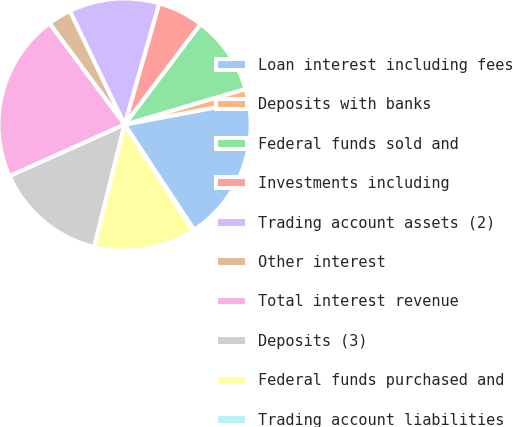Convert chart. <chart><loc_0><loc_0><loc_500><loc_500><pie_chart><fcel>Loan interest including fees<fcel>Deposits with banks<fcel>Federal funds sold and<fcel>Investments including<fcel>Trading account assets (2)<fcel>Other interest<fcel>Total interest revenue<fcel>Deposits (3)<fcel>Federal funds purchased and<fcel>Trading account liabilities<nl><fcel>18.69%<fcel>1.59%<fcel>10.14%<fcel>5.87%<fcel>11.57%<fcel>3.02%<fcel>21.54%<fcel>14.42%<fcel>12.99%<fcel>0.17%<nl></chart> 